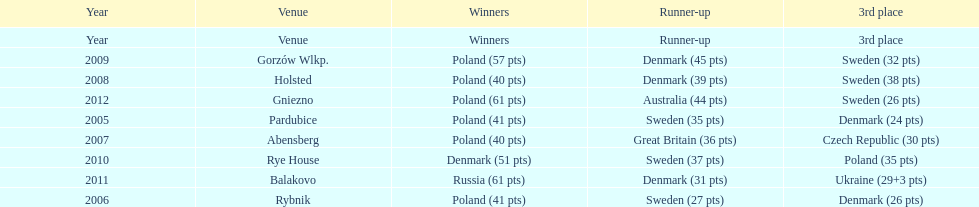What was the difference in final score between russia and denmark in 2011? 30. Could you parse the entire table? {'header': ['Year', 'Venue', 'Winners', 'Runner-up', '3rd place'], 'rows': [['Year', 'Venue', 'Winners', 'Runner-up', '3rd place'], ['2009', 'Gorzów Wlkp.', 'Poland (57 pts)', 'Denmark (45 pts)', 'Sweden (32 pts)'], ['2008', 'Holsted', 'Poland (40 pts)', 'Denmark (39 pts)', 'Sweden (38 pts)'], ['2012', 'Gniezno', 'Poland (61 pts)', 'Australia (44 pts)', 'Sweden (26 pts)'], ['2005', 'Pardubice', 'Poland (41 pts)', 'Sweden (35 pts)', 'Denmark (24 pts)'], ['2007', 'Abensberg', 'Poland (40 pts)', 'Great Britain (36 pts)', 'Czech Republic (30 pts)'], ['2010', 'Rye House', 'Denmark (51 pts)', 'Sweden (37 pts)', 'Poland (35 pts)'], ['2011', 'Balakovo', 'Russia (61 pts)', 'Denmark (31 pts)', 'Ukraine (29+3 pts)'], ['2006', 'Rybnik', 'Poland (41 pts)', 'Sweden (27 pts)', 'Denmark (26 pts)']]} 